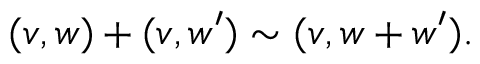Convert formula to latex. <formula><loc_0><loc_0><loc_500><loc_500>( v , w ) + ( v , w ^ { \prime } ) \sim ( v , w + w ^ { \prime } ) .</formula> 